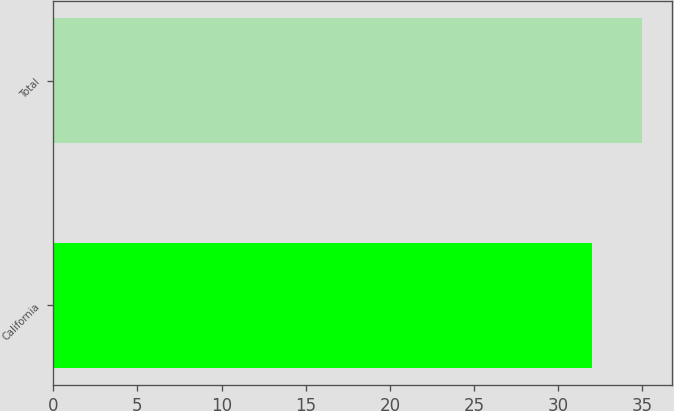<chart> <loc_0><loc_0><loc_500><loc_500><bar_chart><fcel>California<fcel>Total<nl><fcel>32<fcel>35<nl></chart> 